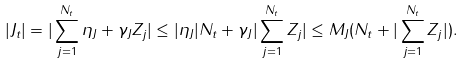<formula> <loc_0><loc_0><loc_500><loc_500>| J _ { t } | & = | \sum _ { j = 1 } ^ { N _ { t } } \eta _ { J } + \gamma _ { J } Z _ { j } | \leq | \eta _ { J } | N _ { t } + \gamma _ { J } | \sum _ { j = 1 } ^ { N _ { t } } Z _ { j } | \leq M _ { J } ( N _ { t } + | \sum _ { j = 1 } ^ { N _ { t } } Z _ { j } | ) .</formula> 